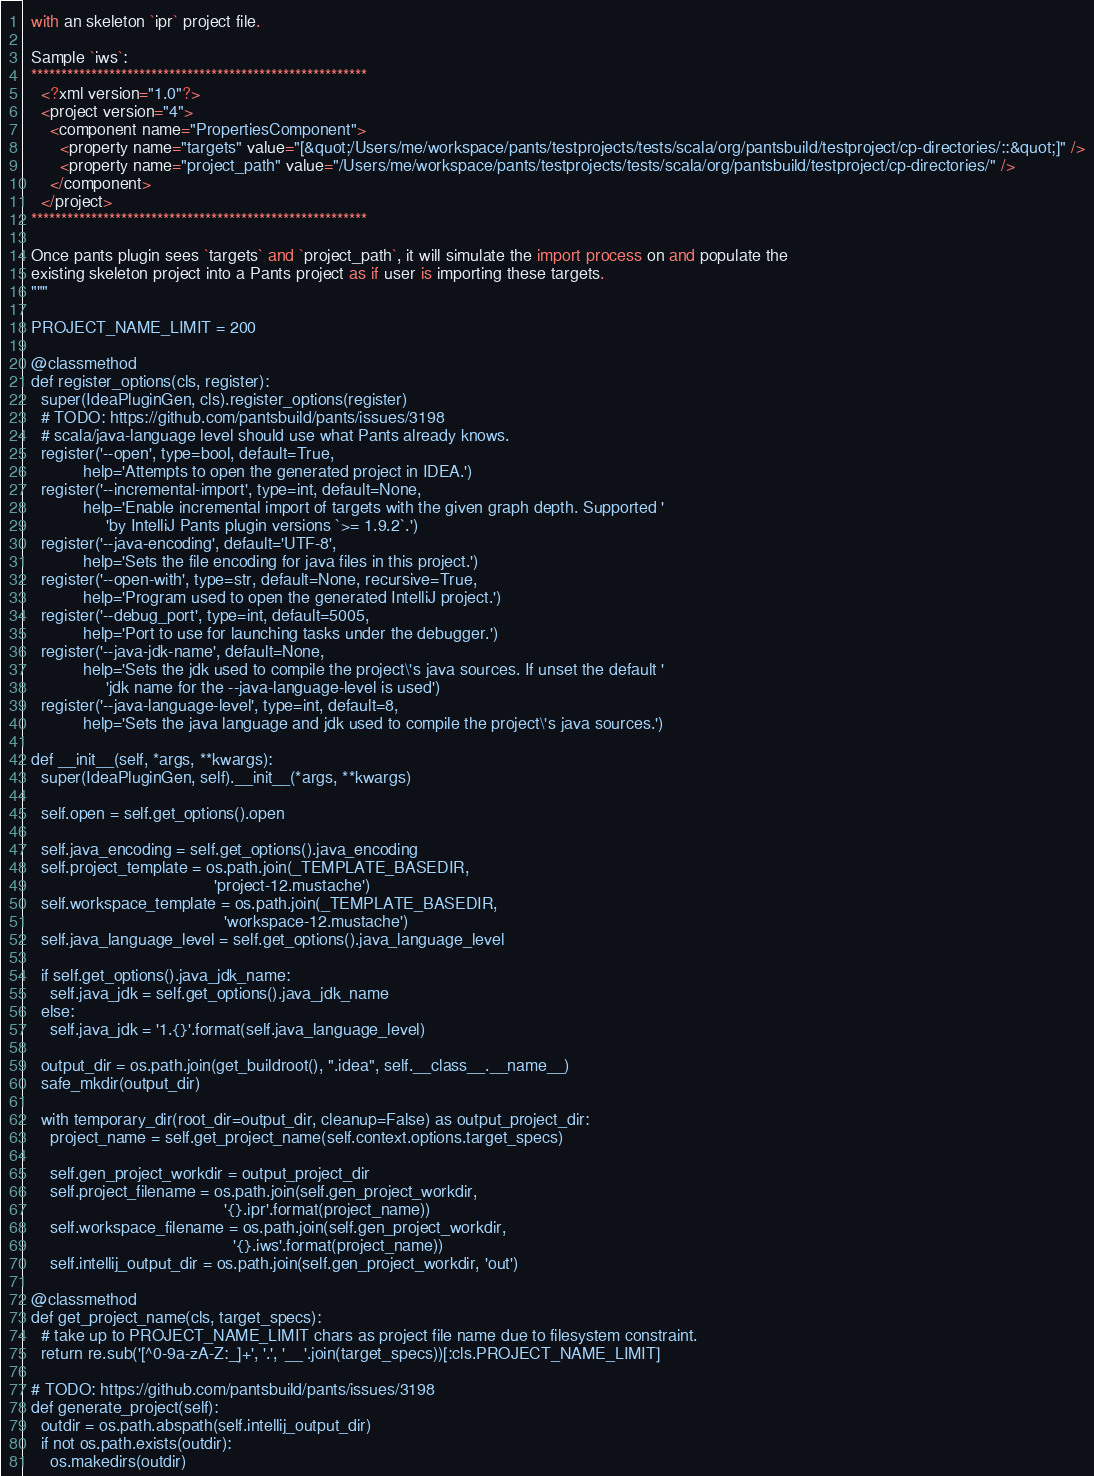<code> <loc_0><loc_0><loc_500><loc_500><_Python_>  with an skeleton `ipr` project file.

  Sample `iws`:
  ********************************************************
    <?xml version="1.0"?>
    <project version="4">
      <component name="PropertiesComponent">
        <property name="targets" value="[&quot;/Users/me/workspace/pants/testprojects/tests/scala/org/pantsbuild/testproject/cp-directories/::&quot;]" />
        <property name="project_path" value="/Users/me/workspace/pants/testprojects/tests/scala/org/pantsbuild/testproject/cp-directories/" />
      </component>
    </project>
  ********************************************************

  Once pants plugin sees `targets` and `project_path`, it will simulate the import process on and populate the
  existing skeleton project into a Pants project as if user is importing these targets.
  """

  PROJECT_NAME_LIMIT = 200

  @classmethod
  def register_options(cls, register):
    super(IdeaPluginGen, cls).register_options(register)
    # TODO: https://github.com/pantsbuild/pants/issues/3198
    # scala/java-language level should use what Pants already knows.
    register('--open', type=bool, default=True,
             help='Attempts to open the generated project in IDEA.')
    register('--incremental-import', type=int, default=None,
             help='Enable incremental import of targets with the given graph depth. Supported '
                  'by IntelliJ Pants plugin versions `>= 1.9.2`.')
    register('--java-encoding', default='UTF-8',
             help='Sets the file encoding for java files in this project.')
    register('--open-with', type=str, default=None, recursive=True,
             help='Program used to open the generated IntelliJ project.')
    register('--debug_port', type=int, default=5005,
             help='Port to use for launching tasks under the debugger.')
    register('--java-jdk-name', default=None,
             help='Sets the jdk used to compile the project\'s java sources. If unset the default '
                  'jdk name for the --java-language-level is used')
    register('--java-language-level', type=int, default=8,
             help='Sets the java language and jdk used to compile the project\'s java sources.')

  def __init__(self, *args, **kwargs):
    super(IdeaPluginGen, self).__init__(*args, **kwargs)

    self.open = self.get_options().open

    self.java_encoding = self.get_options().java_encoding
    self.project_template = os.path.join(_TEMPLATE_BASEDIR,
                                         'project-12.mustache')
    self.workspace_template = os.path.join(_TEMPLATE_BASEDIR,
                                           'workspace-12.mustache')
    self.java_language_level = self.get_options().java_language_level

    if self.get_options().java_jdk_name:
      self.java_jdk = self.get_options().java_jdk_name
    else:
      self.java_jdk = '1.{}'.format(self.java_language_level)

    output_dir = os.path.join(get_buildroot(), ".idea", self.__class__.__name__)
    safe_mkdir(output_dir)

    with temporary_dir(root_dir=output_dir, cleanup=False) as output_project_dir:
      project_name = self.get_project_name(self.context.options.target_specs)

      self.gen_project_workdir = output_project_dir
      self.project_filename = os.path.join(self.gen_project_workdir,
                                           '{}.ipr'.format(project_name))
      self.workspace_filename = os.path.join(self.gen_project_workdir,
                                             '{}.iws'.format(project_name))
      self.intellij_output_dir = os.path.join(self.gen_project_workdir, 'out')

  @classmethod
  def get_project_name(cls, target_specs):
    # take up to PROJECT_NAME_LIMIT chars as project file name due to filesystem constraint.
    return re.sub('[^0-9a-zA-Z:_]+', '.', '__'.join(target_specs))[:cls.PROJECT_NAME_LIMIT]

  # TODO: https://github.com/pantsbuild/pants/issues/3198
  def generate_project(self):
    outdir = os.path.abspath(self.intellij_output_dir)
    if not os.path.exists(outdir):
      os.makedirs(outdir)
</code> 